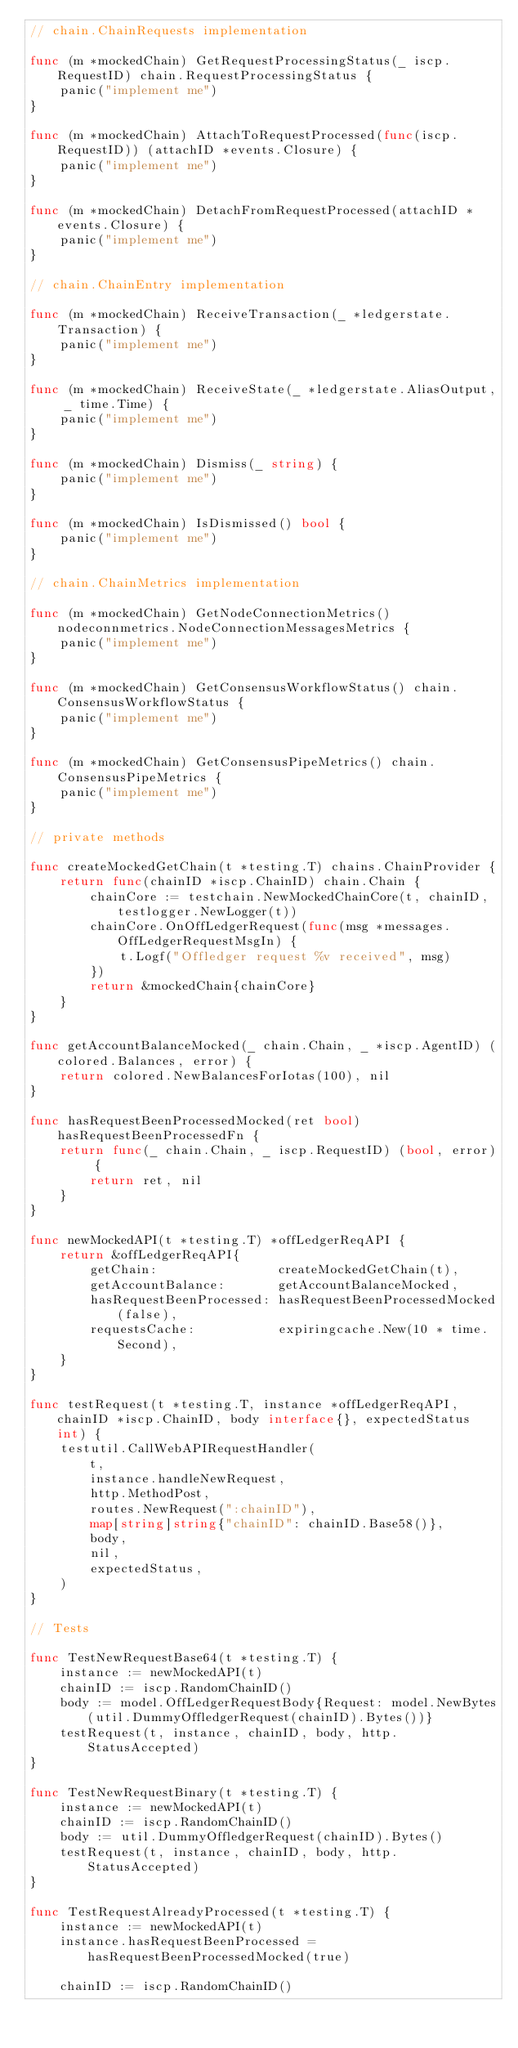Convert code to text. <code><loc_0><loc_0><loc_500><loc_500><_Go_>// chain.ChainRequests implementation

func (m *mockedChain) GetRequestProcessingStatus(_ iscp.RequestID) chain.RequestProcessingStatus {
	panic("implement me")
}

func (m *mockedChain) AttachToRequestProcessed(func(iscp.RequestID)) (attachID *events.Closure) {
	panic("implement me")
}

func (m *mockedChain) DetachFromRequestProcessed(attachID *events.Closure) {
	panic("implement me")
}

// chain.ChainEntry implementation

func (m *mockedChain) ReceiveTransaction(_ *ledgerstate.Transaction) {
	panic("implement me")
}

func (m *mockedChain) ReceiveState(_ *ledgerstate.AliasOutput, _ time.Time) {
	panic("implement me")
}

func (m *mockedChain) Dismiss(_ string) {
	panic("implement me")
}

func (m *mockedChain) IsDismissed() bool {
	panic("implement me")
}

// chain.ChainMetrics implementation

func (m *mockedChain) GetNodeConnectionMetrics() nodeconnmetrics.NodeConnectionMessagesMetrics {
	panic("implement me")
}

func (m *mockedChain) GetConsensusWorkflowStatus() chain.ConsensusWorkflowStatus {
	panic("implement me")
}

func (m *mockedChain) GetConsensusPipeMetrics() chain.ConsensusPipeMetrics {
	panic("implement me")
}

// private methods

func createMockedGetChain(t *testing.T) chains.ChainProvider {
	return func(chainID *iscp.ChainID) chain.Chain {
		chainCore := testchain.NewMockedChainCore(t, chainID, testlogger.NewLogger(t))
		chainCore.OnOffLedgerRequest(func(msg *messages.OffLedgerRequestMsgIn) {
			t.Logf("Offledger request %v received", msg)
		})
		return &mockedChain{chainCore}
	}
}

func getAccountBalanceMocked(_ chain.Chain, _ *iscp.AgentID) (colored.Balances, error) {
	return colored.NewBalancesForIotas(100), nil
}

func hasRequestBeenProcessedMocked(ret bool) hasRequestBeenProcessedFn {
	return func(_ chain.Chain, _ iscp.RequestID) (bool, error) {
		return ret, nil
	}
}

func newMockedAPI(t *testing.T) *offLedgerReqAPI {
	return &offLedgerReqAPI{
		getChain:                createMockedGetChain(t),
		getAccountBalance:       getAccountBalanceMocked,
		hasRequestBeenProcessed: hasRequestBeenProcessedMocked(false),
		requestsCache:           expiringcache.New(10 * time.Second),
	}
}

func testRequest(t *testing.T, instance *offLedgerReqAPI, chainID *iscp.ChainID, body interface{}, expectedStatus int) {
	testutil.CallWebAPIRequestHandler(
		t,
		instance.handleNewRequest,
		http.MethodPost,
		routes.NewRequest(":chainID"),
		map[string]string{"chainID": chainID.Base58()},
		body,
		nil,
		expectedStatus,
	)
}

// Tests

func TestNewRequestBase64(t *testing.T) {
	instance := newMockedAPI(t)
	chainID := iscp.RandomChainID()
	body := model.OffLedgerRequestBody{Request: model.NewBytes(util.DummyOffledgerRequest(chainID).Bytes())}
	testRequest(t, instance, chainID, body, http.StatusAccepted)
}

func TestNewRequestBinary(t *testing.T) {
	instance := newMockedAPI(t)
	chainID := iscp.RandomChainID()
	body := util.DummyOffledgerRequest(chainID).Bytes()
	testRequest(t, instance, chainID, body, http.StatusAccepted)
}

func TestRequestAlreadyProcessed(t *testing.T) {
	instance := newMockedAPI(t)
	instance.hasRequestBeenProcessed = hasRequestBeenProcessedMocked(true)

	chainID := iscp.RandomChainID()</code> 